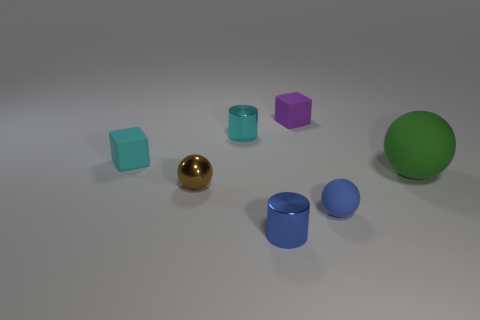There is a blue object to the right of the rubber cube right of the object in front of the tiny blue rubber ball; what shape is it?
Ensure brevity in your answer.  Sphere. There is a small thing that is behind the small brown metal object and right of the small cyan metallic object; what material is it?
Offer a terse response. Rubber. There is a rubber cube to the left of the blue cylinder; is it the same size as the big matte ball?
Make the answer very short. No. Is there anything else that is the same size as the brown shiny ball?
Your answer should be compact. Yes. Are there more small brown things in front of the small cyan matte thing than spheres that are in front of the small metal sphere?
Make the answer very short. No. The shiny object to the left of the small cylinder that is behind the brown thing on the right side of the tiny cyan rubber object is what color?
Ensure brevity in your answer.  Brown. There is a tiny cylinder behind the big object; is it the same color as the large object?
Make the answer very short. No. What number of other objects are there of the same color as the tiny matte ball?
Give a very brief answer. 1. What number of objects are either brown shiny balls or tiny purple rubber things?
Your answer should be very brief. 2. How many objects are big green rubber things or tiny rubber blocks that are in front of the tiny purple matte object?
Your answer should be very brief. 2. 